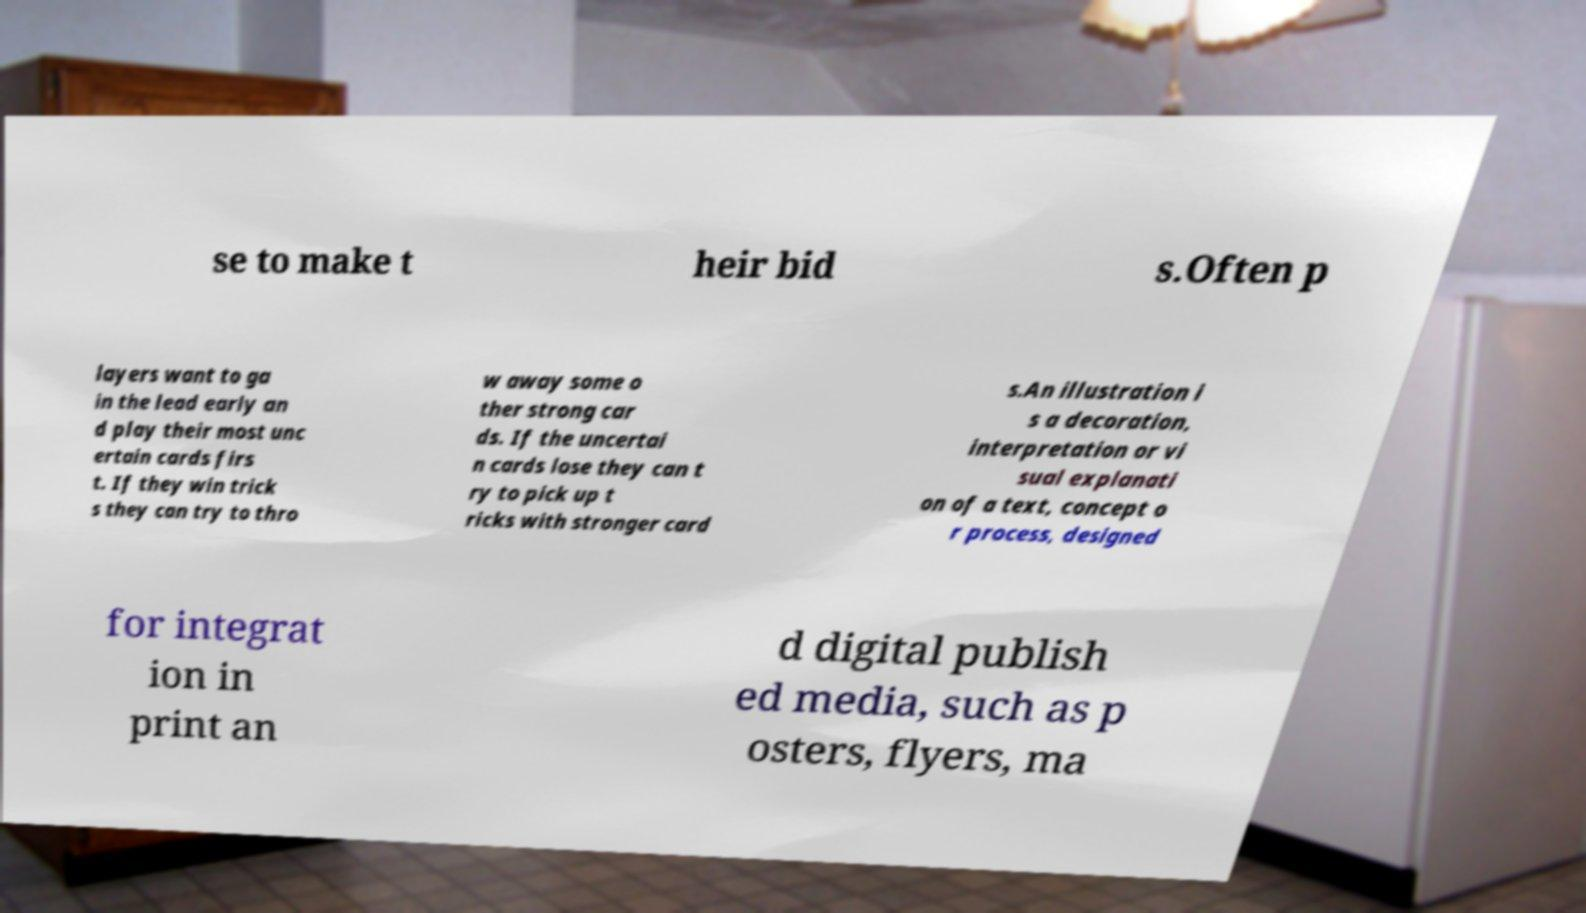Please read and relay the text visible in this image. What does it say? se to make t heir bid s.Often p layers want to ga in the lead early an d play their most unc ertain cards firs t. If they win trick s they can try to thro w away some o ther strong car ds. If the uncertai n cards lose they can t ry to pick up t ricks with stronger card s.An illustration i s a decoration, interpretation or vi sual explanati on of a text, concept o r process, designed for integrat ion in print an d digital publish ed media, such as p osters, flyers, ma 